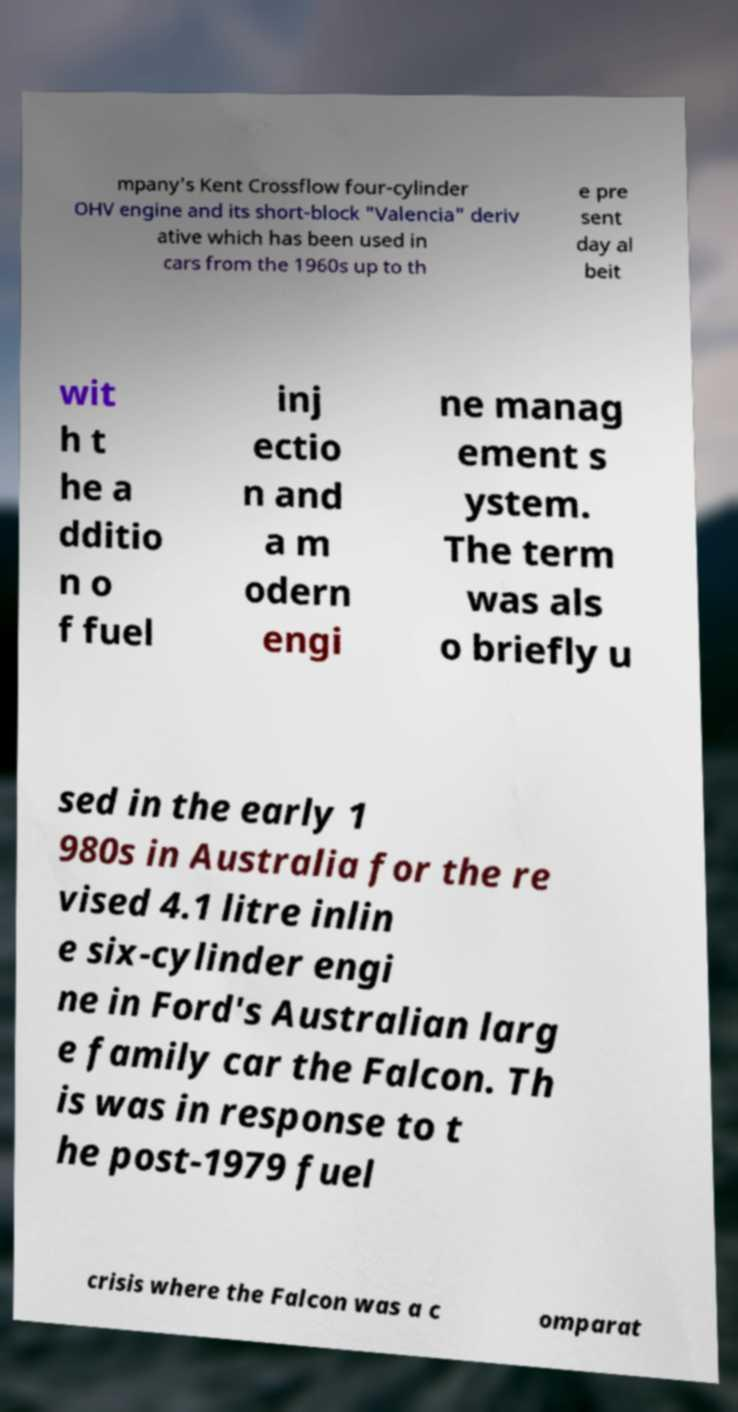Can you accurately transcribe the text from the provided image for me? mpany's Kent Crossflow four-cylinder OHV engine and its short-block "Valencia" deriv ative which has been used in cars from the 1960s up to th e pre sent day al beit wit h t he a dditio n o f fuel inj ectio n and a m odern engi ne manag ement s ystem. The term was als o briefly u sed in the early 1 980s in Australia for the re vised 4.1 litre inlin e six-cylinder engi ne in Ford's Australian larg e family car the Falcon. Th is was in response to t he post-1979 fuel crisis where the Falcon was a c omparat 